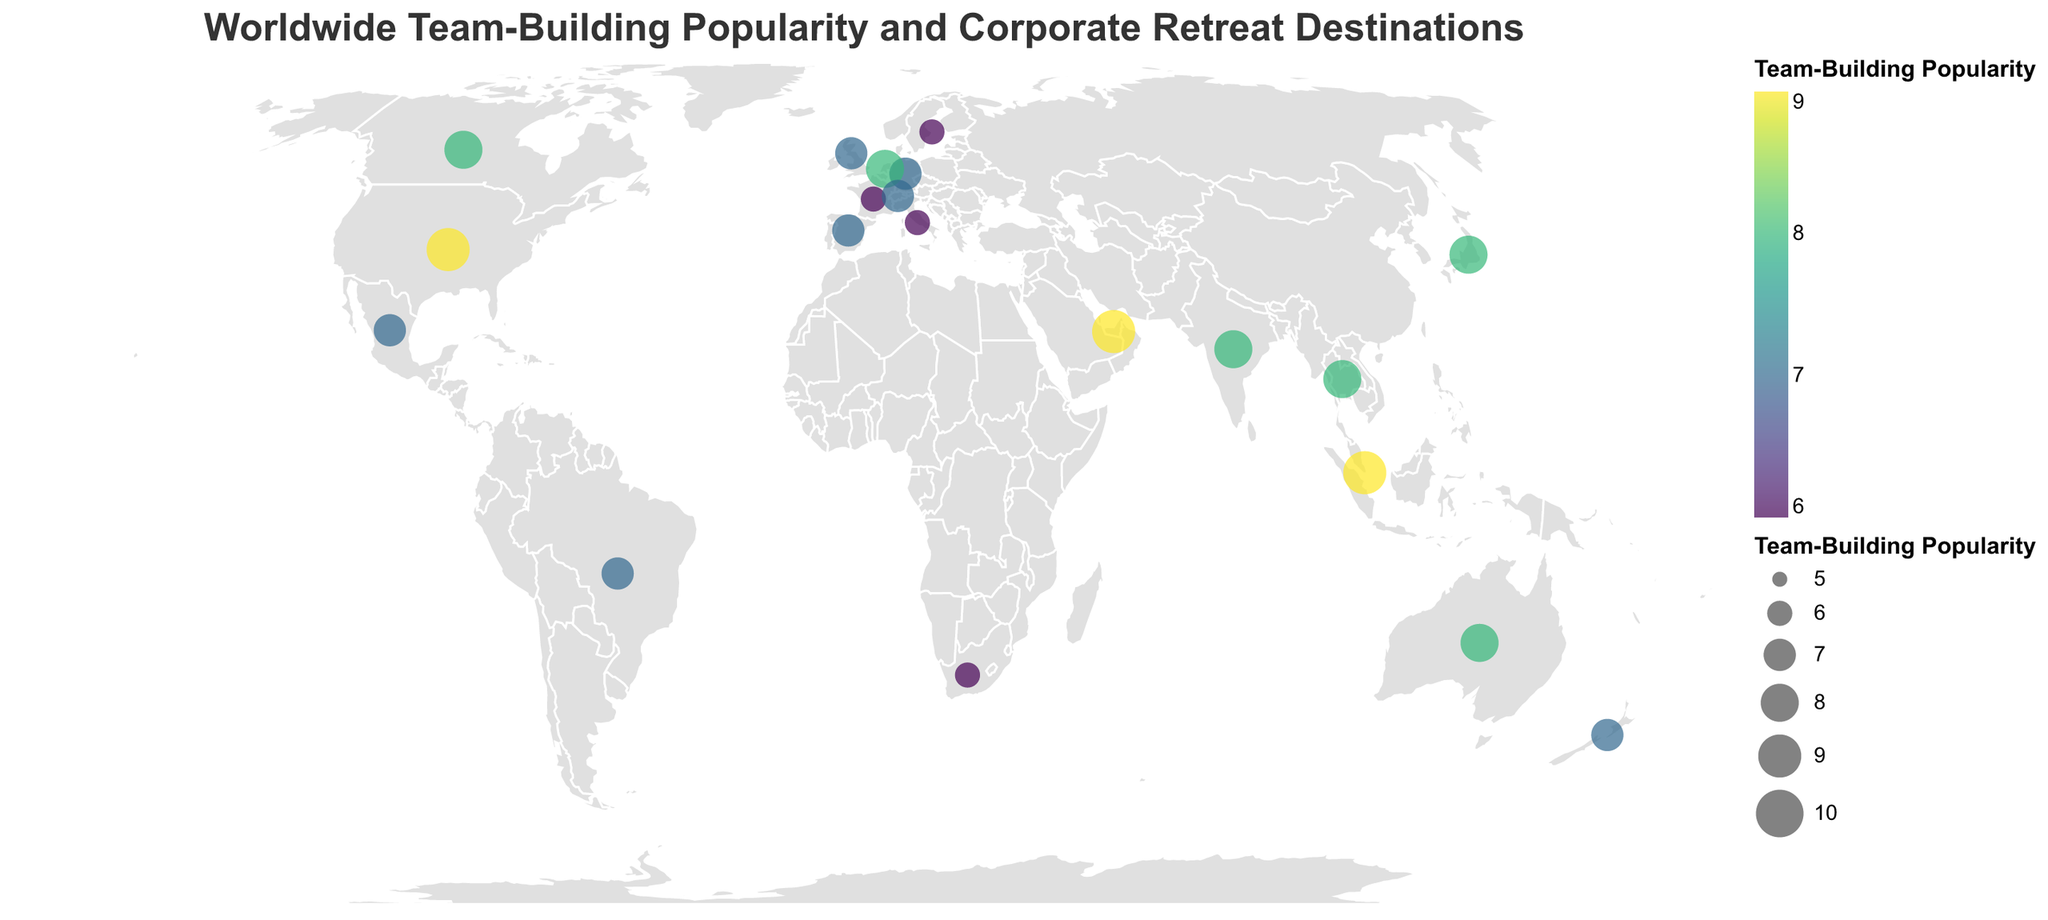What is the title of this figure? The title is displayed prominently at the top of the figure and reads "Worldwide Team-Building Popularity and Corporate Retreat Destinations".
Answer: Worldwide Team-Building Popularity and Corporate Retreat Destinations Which country has the highest team-building popularity? The figure uses size and color to indicate the level of team-building popularity. The United States, Singapore, and the United Arab Emirates have the largest circles with the darkest color, indicating the highest popularity score of 9.
Answer: United States, Singapore, United Arab Emirates What is the most popular team-building activity destination in Japan? By looking at the data point marked on Japan, we observe that the tooltip information or the accompanying legend tells us that the top corporate retreat destination in Japan is Hakone.
Answer: Hakone List all the countries with a team-building popularity score of 8. The map marks each country with a point, colored and sized by their popularity score. By reviewing these points, we can identify that Japan, Australia, Canada, Netherlands, India, and Thailand have a score of 8.
Answer: Japan, Australia, Canada, Netherlands, India, Thailand Which countries have a team-building popularity score of 6, and what are their top retreat destinations? The map uses varying circle sizes and colors to represent different popularity scores. We identify that France, South Africa, Italy, and Sweden all have a score of 6, and their top retreat destinations are Provence, Kruger National Park, Tuscany, and Åre respectively.
Answer: France: Provence; South Africa: Kruger National Park; Italy: Tuscany; Sweden: Åre Compare the team-building popularity of Brazil and Spain. Which one is higher? We find the circles representing Brazil and Spain. Both have similar-sized circles and are colored the same, indicating both have a team-building popularity score of 7.
Answer: Both are equal What is the most popular corporate retreat destination in Singapore? By looking at the Singapore data point, we observe that the tooltip information or the accompanying legend tells us that the top corporate retreat destination in Singapore is Sentosa Island.
Answer: Sentosa Island Which country in the figure is represented by the circle located furthest southwest? The furthest southwest position corresponds to a circle near the bottom left of the globe. This is the circle representing New Zealand, with Queenstown as the retreat destination.
Answer: New Zealand Identify the country with the retreat destination "Goa" and its team-building popularity score. The figure shows Goa associated with the data point located over India. The circle's size and color indicate a team-building popularity score of 8.
Answer: India; 8 How many countries have a team-building popularity score greater than 7? Review the circles to find those with a score greater than 7. This includes the United States, Japan, Australia, Canada, Singapore, Netherlands, India, United Arab Emirates, and Thailand, making a total of 9 countries.
Answer: Nine 